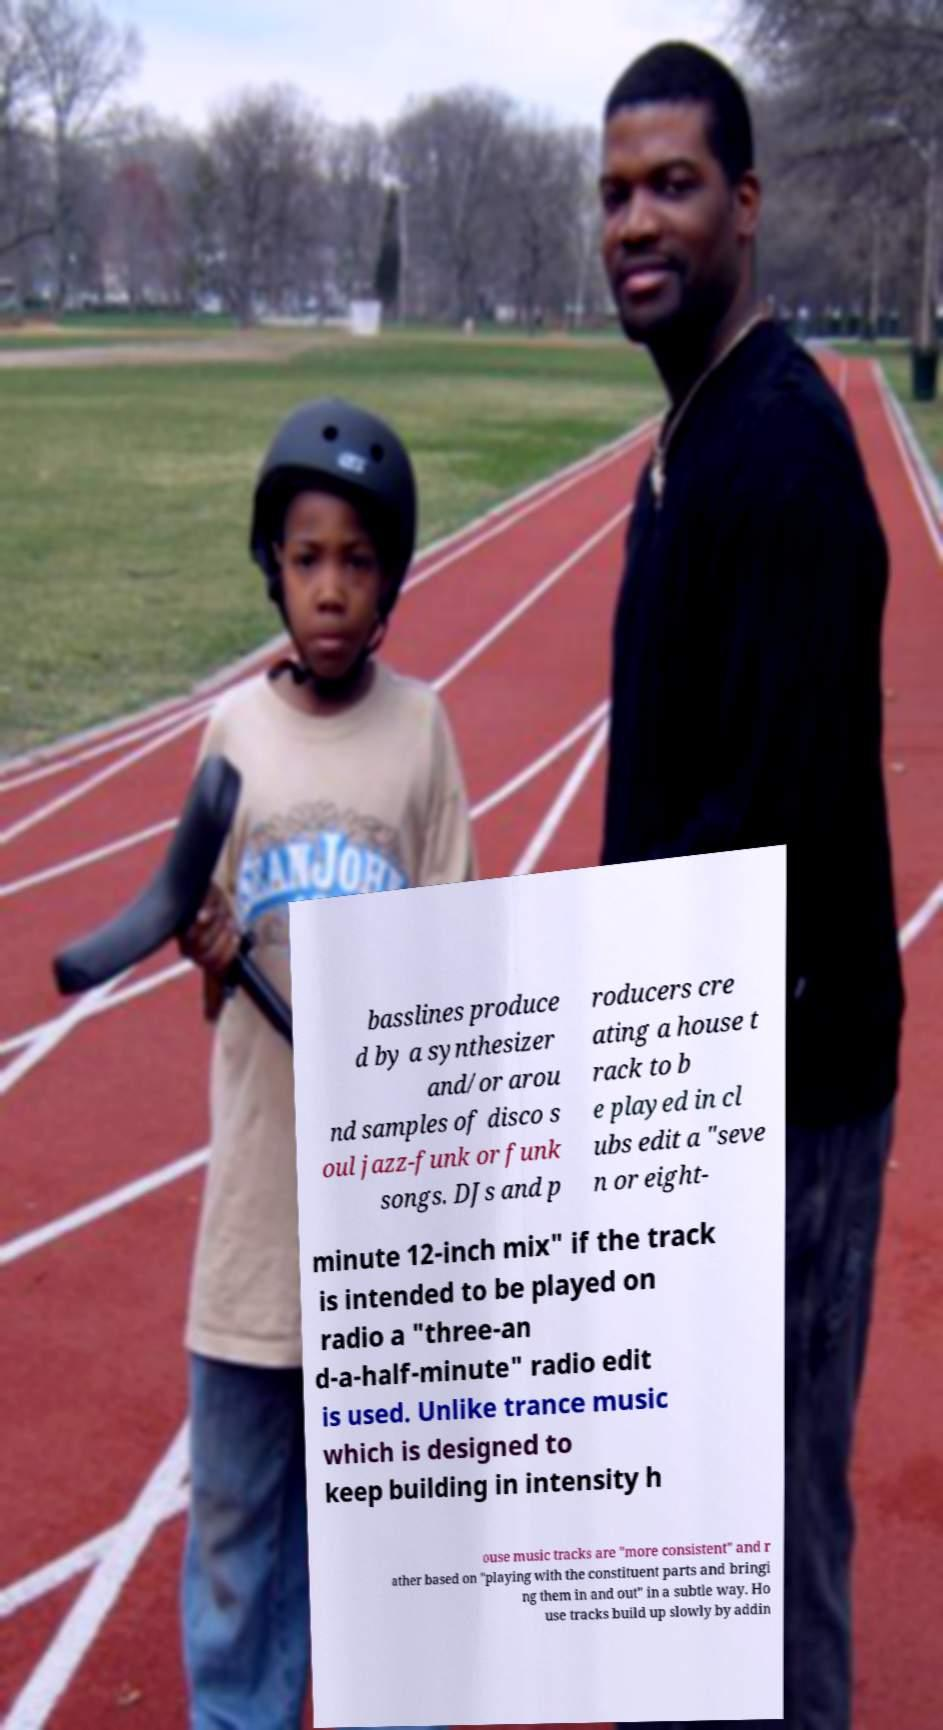For documentation purposes, I need the text within this image transcribed. Could you provide that? basslines produce d by a synthesizer and/or arou nd samples of disco s oul jazz-funk or funk songs. DJs and p roducers cre ating a house t rack to b e played in cl ubs edit a "seve n or eight- minute 12-inch mix" if the track is intended to be played on radio a "three-an d-a-half-minute" radio edit is used. Unlike trance music which is designed to keep building in intensity h ouse music tracks are "more consistent" and r ather based on "playing with the constituent parts and bringi ng them in and out" in a subtle way. Ho use tracks build up slowly by addin 